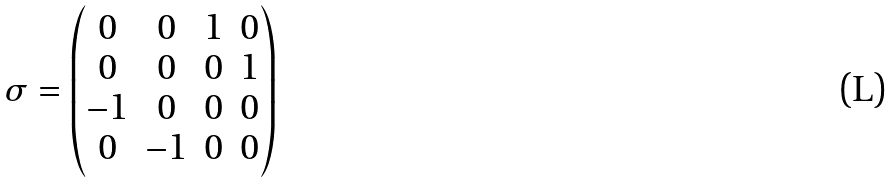<formula> <loc_0><loc_0><loc_500><loc_500>\sigma = \begin{pmatrix} 0 & 0 & 1 & 0 \\ 0 & 0 & 0 & 1 \\ - 1 & 0 & 0 & 0 \\ 0 & - 1 & 0 & 0 \end{pmatrix}</formula> 